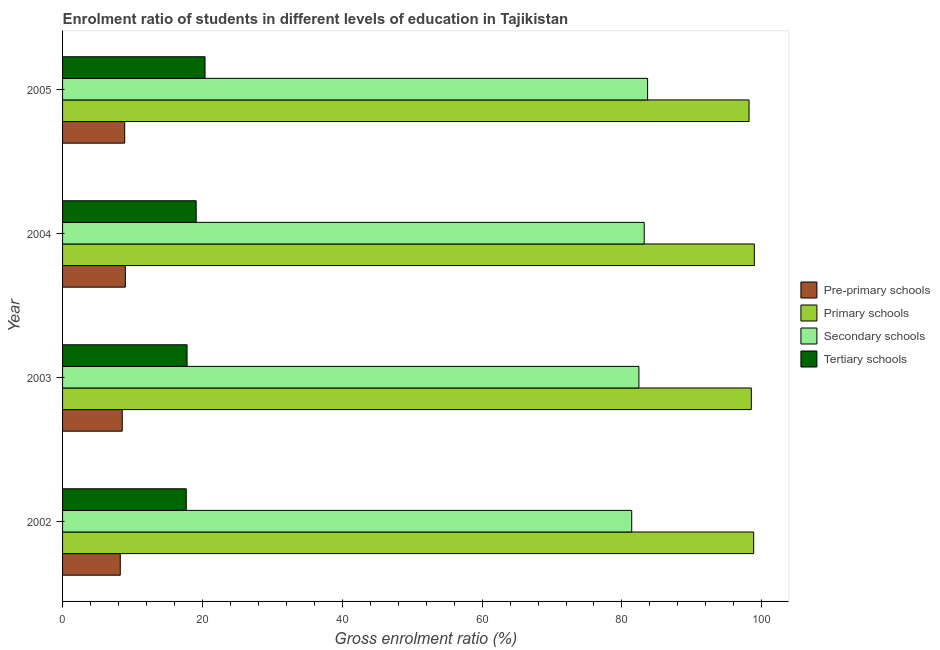How many bars are there on the 2nd tick from the top?
Keep it short and to the point. 4. How many bars are there on the 3rd tick from the bottom?
Keep it short and to the point. 4. What is the label of the 3rd group of bars from the top?
Your answer should be compact. 2003. In how many cases, is the number of bars for a given year not equal to the number of legend labels?
Offer a very short reply. 0. What is the gross enrolment ratio in pre-primary schools in 2005?
Provide a succinct answer. 8.88. Across all years, what is the maximum gross enrolment ratio in tertiary schools?
Your response must be concise. 20.38. Across all years, what is the minimum gross enrolment ratio in tertiary schools?
Provide a short and direct response. 17.69. In which year was the gross enrolment ratio in tertiary schools maximum?
Make the answer very short. 2005. In which year was the gross enrolment ratio in tertiary schools minimum?
Give a very brief answer. 2002. What is the total gross enrolment ratio in tertiary schools in the graph?
Ensure brevity in your answer.  74.98. What is the difference between the gross enrolment ratio in secondary schools in 2003 and that in 2004?
Provide a short and direct response. -0.76. What is the difference between the gross enrolment ratio in primary schools in 2003 and the gross enrolment ratio in tertiary schools in 2002?
Keep it short and to the point. 80.82. What is the average gross enrolment ratio in pre-primary schools per year?
Offer a terse response. 8.66. In the year 2003, what is the difference between the gross enrolment ratio in pre-primary schools and gross enrolment ratio in primary schools?
Keep it short and to the point. -89.97. What is the ratio of the gross enrolment ratio in tertiary schools in 2002 to that in 2003?
Your response must be concise. 0.99. What is the difference between the highest and the second highest gross enrolment ratio in tertiary schools?
Make the answer very short. 1.27. What is the difference between the highest and the lowest gross enrolment ratio in tertiary schools?
Provide a succinct answer. 2.69. In how many years, is the gross enrolment ratio in tertiary schools greater than the average gross enrolment ratio in tertiary schools taken over all years?
Your answer should be very brief. 2. Is the sum of the gross enrolment ratio in secondary schools in 2003 and 2004 greater than the maximum gross enrolment ratio in pre-primary schools across all years?
Keep it short and to the point. Yes. What does the 3rd bar from the top in 2004 represents?
Provide a succinct answer. Primary schools. What does the 4th bar from the bottom in 2005 represents?
Provide a succinct answer. Tertiary schools. Is it the case that in every year, the sum of the gross enrolment ratio in pre-primary schools and gross enrolment ratio in primary schools is greater than the gross enrolment ratio in secondary schools?
Offer a very short reply. Yes. How many bars are there?
Give a very brief answer. 16. What is the difference between two consecutive major ticks on the X-axis?
Make the answer very short. 20. Are the values on the major ticks of X-axis written in scientific E-notation?
Keep it short and to the point. No. Where does the legend appear in the graph?
Provide a short and direct response. Center right. How many legend labels are there?
Offer a very short reply. 4. How are the legend labels stacked?
Keep it short and to the point. Vertical. What is the title of the graph?
Your answer should be very brief. Enrolment ratio of students in different levels of education in Tajikistan. What is the Gross enrolment ratio (%) in Pre-primary schools in 2002?
Keep it short and to the point. 8.25. What is the Gross enrolment ratio (%) in Primary schools in 2002?
Your answer should be compact. 98.84. What is the Gross enrolment ratio (%) of Secondary schools in 2002?
Your answer should be compact. 81.4. What is the Gross enrolment ratio (%) in Tertiary schools in 2002?
Your answer should be very brief. 17.69. What is the Gross enrolment ratio (%) of Pre-primary schools in 2003?
Make the answer very short. 8.54. What is the Gross enrolment ratio (%) of Primary schools in 2003?
Give a very brief answer. 98.51. What is the Gross enrolment ratio (%) in Secondary schools in 2003?
Make the answer very short. 82.43. What is the Gross enrolment ratio (%) of Tertiary schools in 2003?
Give a very brief answer. 17.8. What is the Gross enrolment ratio (%) in Pre-primary schools in 2004?
Your response must be concise. 8.98. What is the Gross enrolment ratio (%) in Primary schools in 2004?
Provide a short and direct response. 98.93. What is the Gross enrolment ratio (%) in Secondary schools in 2004?
Give a very brief answer. 83.19. What is the Gross enrolment ratio (%) in Tertiary schools in 2004?
Ensure brevity in your answer.  19.11. What is the Gross enrolment ratio (%) in Pre-primary schools in 2005?
Offer a terse response. 8.88. What is the Gross enrolment ratio (%) of Primary schools in 2005?
Keep it short and to the point. 98.18. What is the Gross enrolment ratio (%) of Secondary schools in 2005?
Your answer should be compact. 83.67. What is the Gross enrolment ratio (%) of Tertiary schools in 2005?
Offer a very short reply. 20.38. Across all years, what is the maximum Gross enrolment ratio (%) in Pre-primary schools?
Your answer should be compact. 8.98. Across all years, what is the maximum Gross enrolment ratio (%) in Primary schools?
Your answer should be compact. 98.93. Across all years, what is the maximum Gross enrolment ratio (%) of Secondary schools?
Keep it short and to the point. 83.67. Across all years, what is the maximum Gross enrolment ratio (%) in Tertiary schools?
Provide a succinct answer. 20.38. Across all years, what is the minimum Gross enrolment ratio (%) of Pre-primary schools?
Ensure brevity in your answer.  8.25. Across all years, what is the minimum Gross enrolment ratio (%) of Primary schools?
Provide a short and direct response. 98.18. Across all years, what is the minimum Gross enrolment ratio (%) in Secondary schools?
Your response must be concise. 81.4. Across all years, what is the minimum Gross enrolment ratio (%) of Tertiary schools?
Offer a terse response. 17.69. What is the total Gross enrolment ratio (%) in Pre-primary schools in the graph?
Keep it short and to the point. 34.65. What is the total Gross enrolment ratio (%) of Primary schools in the graph?
Provide a short and direct response. 394.47. What is the total Gross enrolment ratio (%) in Secondary schools in the graph?
Ensure brevity in your answer.  330.69. What is the total Gross enrolment ratio (%) of Tertiary schools in the graph?
Ensure brevity in your answer.  74.98. What is the difference between the Gross enrolment ratio (%) in Pre-primary schools in 2002 and that in 2003?
Provide a short and direct response. -0.28. What is the difference between the Gross enrolment ratio (%) of Primary schools in 2002 and that in 2003?
Your answer should be compact. 0.34. What is the difference between the Gross enrolment ratio (%) in Secondary schools in 2002 and that in 2003?
Your answer should be very brief. -1.03. What is the difference between the Gross enrolment ratio (%) of Tertiary schools in 2002 and that in 2003?
Provide a short and direct response. -0.11. What is the difference between the Gross enrolment ratio (%) in Pre-primary schools in 2002 and that in 2004?
Offer a very short reply. -0.72. What is the difference between the Gross enrolment ratio (%) of Primary schools in 2002 and that in 2004?
Offer a terse response. -0.09. What is the difference between the Gross enrolment ratio (%) in Secondary schools in 2002 and that in 2004?
Offer a very short reply. -1.79. What is the difference between the Gross enrolment ratio (%) in Tertiary schools in 2002 and that in 2004?
Your answer should be compact. -1.42. What is the difference between the Gross enrolment ratio (%) of Pre-primary schools in 2002 and that in 2005?
Provide a succinct answer. -0.63. What is the difference between the Gross enrolment ratio (%) in Primary schools in 2002 and that in 2005?
Provide a short and direct response. 0.66. What is the difference between the Gross enrolment ratio (%) of Secondary schools in 2002 and that in 2005?
Give a very brief answer. -2.27. What is the difference between the Gross enrolment ratio (%) of Tertiary schools in 2002 and that in 2005?
Offer a very short reply. -2.69. What is the difference between the Gross enrolment ratio (%) in Pre-primary schools in 2003 and that in 2004?
Your answer should be compact. -0.44. What is the difference between the Gross enrolment ratio (%) of Primary schools in 2003 and that in 2004?
Give a very brief answer. -0.43. What is the difference between the Gross enrolment ratio (%) of Secondary schools in 2003 and that in 2004?
Your answer should be very brief. -0.76. What is the difference between the Gross enrolment ratio (%) of Tertiary schools in 2003 and that in 2004?
Keep it short and to the point. -1.3. What is the difference between the Gross enrolment ratio (%) of Pre-primary schools in 2003 and that in 2005?
Ensure brevity in your answer.  -0.35. What is the difference between the Gross enrolment ratio (%) in Primary schools in 2003 and that in 2005?
Offer a terse response. 0.33. What is the difference between the Gross enrolment ratio (%) in Secondary schools in 2003 and that in 2005?
Provide a short and direct response. -1.24. What is the difference between the Gross enrolment ratio (%) in Tertiary schools in 2003 and that in 2005?
Offer a very short reply. -2.57. What is the difference between the Gross enrolment ratio (%) of Pre-primary schools in 2004 and that in 2005?
Offer a terse response. 0.09. What is the difference between the Gross enrolment ratio (%) in Primary schools in 2004 and that in 2005?
Your answer should be very brief. 0.75. What is the difference between the Gross enrolment ratio (%) of Secondary schools in 2004 and that in 2005?
Your response must be concise. -0.49. What is the difference between the Gross enrolment ratio (%) of Tertiary schools in 2004 and that in 2005?
Your answer should be compact. -1.27. What is the difference between the Gross enrolment ratio (%) in Pre-primary schools in 2002 and the Gross enrolment ratio (%) in Primary schools in 2003?
Your answer should be very brief. -90.26. What is the difference between the Gross enrolment ratio (%) in Pre-primary schools in 2002 and the Gross enrolment ratio (%) in Secondary schools in 2003?
Your answer should be very brief. -74.18. What is the difference between the Gross enrolment ratio (%) of Pre-primary schools in 2002 and the Gross enrolment ratio (%) of Tertiary schools in 2003?
Give a very brief answer. -9.55. What is the difference between the Gross enrolment ratio (%) of Primary schools in 2002 and the Gross enrolment ratio (%) of Secondary schools in 2003?
Give a very brief answer. 16.41. What is the difference between the Gross enrolment ratio (%) in Primary schools in 2002 and the Gross enrolment ratio (%) in Tertiary schools in 2003?
Provide a short and direct response. 81.04. What is the difference between the Gross enrolment ratio (%) of Secondary schools in 2002 and the Gross enrolment ratio (%) of Tertiary schools in 2003?
Your answer should be very brief. 63.6. What is the difference between the Gross enrolment ratio (%) of Pre-primary schools in 2002 and the Gross enrolment ratio (%) of Primary schools in 2004?
Your answer should be very brief. -90.68. What is the difference between the Gross enrolment ratio (%) in Pre-primary schools in 2002 and the Gross enrolment ratio (%) in Secondary schools in 2004?
Your answer should be very brief. -74.93. What is the difference between the Gross enrolment ratio (%) of Pre-primary schools in 2002 and the Gross enrolment ratio (%) of Tertiary schools in 2004?
Your response must be concise. -10.86. What is the difference between the Gross enrolment ratio (%) in Primary schools in 2002 and the Gross enrolment ratio (%) in Secondary schools in 2004?
Provide a succinct answer. 15.66. What is the difference between the Gross enrolment ratio (%) of Primary schools in 2002 and the Gross enrolment ratio (%) of Tertiary schools in 2004?
Give a very brief answer. 79.73. What is the difference between the Gross enrolment ratio (%) of Secondary schools in 2002 and the Gross enrolment ratio (%) of Tertiary schools in 2004?
Offer a terse response. 62.29. What is the difference between the Gross enrolment ratio (%) of Pre-primary schools in 2002 and the Gross enrolment ratio (%) of Primary schools in 2005?
Keep it short and to the point. -89.93. What is the difference between the Gross enrolment ratio (%) in Pre-primary schools in 2002 and the Gross enrolment ratio (%) in Secondary schools in 2005?
Offer a terse response. -75.42. What is the difference between the Gross enrolment ratio (%) of Pre-primary schools in 2002 and the Gross enrolment ratio (%) of Tertiary schools in 2005?
Give a very brief answer. -12.12. What is the difference between the Gross enrolment ratio (%) of Primary schools in 2002 and the Gross enrolment ratio (%) of Secondary schools in 2005?
Offer a terse response. 15.17. What is the difference between the Gross enrolment ratio (%) in Primary schools in 2002 and the Gross enrolment ratio (%) in Tertiary schools in 2005?
Give a very brief answer. 78.47. What is the difference between the Gross enrolment ratio (%) in Secondary schools in 2002 and the Gross enrolment ratio (%) in Tertiary schools in 2005?
Your answer should be very brief. 61.03. What is the difference between the Gross enrolment ratio (%) of Pre-primary schools in 2003 and the Gross enrolment ratio (%) of Primary schools in 2004?
Keep it short and to the point. -90.4. What is the difference between the Gross enrolment ratio (%) of Pre-primary schools in 2003 and the Gross enrolment ratio (%) of Secondary schools in 2004?
Your response must be concise. -74.65. What is the difference between the Gross enrolment ratio (%) of Pre-primary schools in 2003 and the Gross enrolment ratio (%) of Tertiary schools in 2004?
Give a very brief answer. -10.57. What is the difference between the Gross enrolment ratio (%) in Primary schools in 2003 and the Gross enrolment ratio (%) in Secondary schools in 2004?
Offer a terse response. 15.32. What is the difference between the Gross enrolment ratio (%) in Primary schools in 2003 and the Gross enrolment ratio (%) in Tertiary schools in 2004?
Your answer should be compact. 79.4. What is the difference between the Gross enrolment ratio (%) of Secondary schools in 2003 and the Gross enrolment ratio (%) of Tertiary schools in 2004?
Your answer should be very brief. 63.32. What is the difference between the Gross enrolment ratio (%) of Pre-primary schools in 2003 and the Gross enrolment ratio (%) of Primary schools in 2005?
Make the answer very short. -89.65. What is the difference between the Gross enrolment ratio (%) in Pre-primary schools in 2003 and the Gross enrolment ratio (%) in Secondary schools in 2005?
Give a very brief answer. -75.14. What is the difference between the Gross enrolment ratio (%) in Pre-primary schools in 2003 and the Gross enrolment ratio (%) in Tertiary schools in 2005?
Provide a short and direct response. -11.84. What is the difference between the Gross enrolment ratio (%) in Primary schools in 2003 and the Gross enrolment ratio (%) in Secondary schools in 2005?
Your answer should be compact. 14.83. What is the difference between the Gross enrolment ratio (%) in Primary schools in 2003 and the Gross enrolment ratio (%) in Tertiary schools in 2005?
Give a very brief answer. 78.13. What is the difference between the Gross enrolment ratio (%) in Secondary schools in 2003 and the Gross enrolment ratio (%) in Tertiary schools in 2005?
Your answer should be very brief. 62.05. What is the difference between the Gross enrolment ratio (%) of Pre-primary schools in 2004 and the Gross enrolment ratio (%) of Primary schools in 2005?
Offer a very short reply. -89.21. What is the difference between the Gross enrolment ratio (%) of Pre-primary schools in 2004 and the Gross enrolment ratio (%) of Secondary schools in 2005?
Ensure brevity in your answer.  -74.7. What is the difference between the Gross enrolment ratio (%) in Pre-primary schools in 2004 and the Gross enrolment ratio (%) in Tertiary schools in 2005?
Provide a succinct answer. -11.4. What is the difference between the Gross enrolment ratio (%) in Primary schools in 2004 and the Gross enrolment ratio (%) in Secondary schools in 2005?
Provide a short and direct response. 15.26. What is the difference between the Gross enrolment ratio (%) in Primary schools in 2004 and the Gross enrolment ratio (%) in Tertiary schools in 2005?
Provide a succinct answer. 78.56. What is the difference between the Gross enrolment ratio (%) in Secondary schools in 2004 and the Gross enrolment ratio (%) in Tertiary schools in 2005?
Keep it short and to the point. 62.81. What is the average Gross enrolment ratio (%) of Pre-primary schools per year?
Provide a succinct answer. 8.66. What is the average Gross enrolment ratio (%) of Primary schools per year?
Give a very brief answer. 98.62. What is the average Gross enrolment ratio (%) of Secondary schools per year?
Provide a succinct answer. 82.67. What is the average Gross enrolment ratio (%) in Tertiary schools per year?
Offer a terse response. 18.74. In the year 2002, what is the difference between the Gross enrolment ratio (%) of Pre-primary schools and Gross enrolment ratio (%) of Primary schools?
Provide a short and direct response. -90.59. In the year 2002, what is the difference between the Gross enrolment ratio (%) of Pre-primary schools and Gross enrolment ratio (%) of Secondary schools?
Your answer should be very brief. -73.15. In the year 2002, what is the difference between the Gross enrolment ratio (%) in Pre-primary schools and Gross enrolment ratio (%) in Tertiary schools?
Ensure brevity in your answer.  -9.44. In the year 2002, what is the difference between the Gross enrolment ratio (%) in Primary schools and Gross enrolment ratio (%) in Secondary schools?
Offer a terse response. 17.44. In the year 2002, what is the difference between the Gross enrolment ratio (%) of Primary schools and Gross enrolment ratio (%) of Tertiary schools?
Keep it short and to the point. 81.15. In the year 2002, what is the difference between the Gross enrolment ratio (%) in Secondary schools and Gross enrolment ratio (%) in Tertiary schools?
Offer a very short reply. 63.71. In the year 2003, what is the difference between the Gross enrolment ratio (%) in Pre-primary schools and Gross enrolment ratio (%) in Primary schools?
Offer a very short reply. -89.97. In the year 2003, what is the difference between the Gross enrolment ratio (%) of Pre-primary schools and Gross enrolment ratio (%) of Secondary schools?
Make the answer very short. -73.89. In the year 2003, what is the difference between the Gross enrolment ratio (%) of Pre-primary schools and Gross enrolment ratio (%) of Tertiary schools?
Ensure brevity in your answer.  -9.27. In the year 2003, what is the difference between the Gross enrolment ratio (%) in Primary schools and Gross enrolment ratio (%) in Secondary schools?
Ensure brevity in your answer.  16.08. In the year 2003, what is the difference between the Gross enrolment ratio (%) of Primary schools and Gross enrolment ratio (%) of Tertiary schools?
Provide a short and direct response. 80.7. In the year 2003, what is the difference between the Gross enrolment ratio (%) in Secondary schools and Gross enrolment ratio (%) in Tertiary schools?
Make the answer very short. 64.62. In the year 2004, what is the difference between the Gross enrolment ratio (%) in Pre-primary schools and Gross enrolment ratio (%) in Primary schools?
Provide a short and direct response. -89.96. In the year 2004, what is the difference between the Gross enrolment ratio (%) in Pre-primary schools and Gross enrolment ratio (%) in Secondary schools?
Offer a very short reply. -74.21. In the year 2004, what is the difference between the Gross enrolment ratio (%) in Pre-primary schools and Gross enrolment ratio (%) in Tertiary schools?
Give a very brief answer. -10.13. In the year 2004, what is the difference between the Gross enrolment ratio (%) of Primary schools and Gross enrolment ratio (%) of Secondary schools?
Your answer should be compact. 15.75. In the year 2004, what is the difference between the Gross enrolment ratio (%) of Primary schools and Gross enrolment ratio (%) of Tertiary schools?
Provide a succinct answer. 79.82. In the year 2004, what is the difference between the Gross enrolment ratio (%) of Secondary schools and Gross enrolment ratio (%) of Tertiary schools?
Keep it short and to the point. 64.08. In the year 2005, what is the difference between the Gross enrolment ratio (%) in Pre-primary schools and Gross enrolment ratio (%) in Primary schools?
Your answer should be very brief. -89.3. In the year 2005, what is the difference between the Gross enrolment ratio (%) of Pre-primary schools and Gross enrolment ratio (%) of Secondary schools?
Keep it short and to the point. -74.79. In the year 2005, what is the difference between the Gross enrolment ratio (%) of Pre-primary schools and Gross enrolment ratio (%) of Tertiary schools?
Your answer should be very brief. -11.49. In the year 2005, what is the difference between the Gross enrolment ratio (%) in Primary schools and Gross enrolment ratio (%) in Secondary schools?
Provide a succinct answer. 14.51. In the year 2005, what is the difference between the Gross enrolment ratio (%) of Primary schools and Gross enrolment ratio (%) of Tertiary schools?
Offer a very short reply. 77.81. In the year 2005, what is the difference between the Gross enrolment ratio (%) of Secondary schools and Gross enrolment ratio (%) of Tertiary schools?
Offer a terse response. 63.3. What is the ratio of the Gross enrolment ratio (%) of Pre-primary schools in 2002 to that in 2003?
Keep it short and to the point. 0.97. What is the ratio of the Gross enrolment ratio (%) in Primary schools in 2002 to that in 2003?
Provide a short and direct response. 1. What is the ratio of the Gross enrolment ratio (%) of Secondary schools in 2002 to that in 2003?
Offer a very short reply. 0.99. What is the ratio of the Gross enrolment ratio (%) of Tertiary schools in 2002 to that in 2003?
Your answer should be very brief. 0.99. What is the ratio of the Gross enrolment ratio (%) of Pre-primary schools in 2002 to that in 2004?
Give a very brief answer. 0.92. What is the ratio of the Gross enrolment ratio (%) in Secondary schools in 2002 to that in 2004?
Provide a succinct answer. 0.98. What is the ratio of the Gross enrolment ratio (%) in Tertiary schools in 2002 to that in 2004?
Provide a short and direct response. 0.93. What is the ratio of the Gross enrolment ratio (%) in Pre-primary schools in 2002 to that in 2005?
Provide a succinct answer. 0.93. What is the ratio of the Gross enrolment ratio (%) of Secondary schools in 2002 to that in 2005?
Your response must be concise. 0.97. What is the ratio of the Gross enrolment ratio (%) of Tertiary schools in 2002 to that in 2005?
Your answer should be compact. 0.87. What is the ratio of the Gross enrolment ratio (%) in Pre-primary schools in 2003 to that in 2004?
Offer a terse response. 0.95. What is the ratio of the Gross enrolment ratio (%) in Primary schools in 2003 to that in 2004?
Keep it short and to the point. 1. What is the ratio of the Gross enrolment ratio (%) in Secondary schools in 2003 to that in 2004?
Your answer should be very brief. 0.99. What is the ratio of the Gross enrolment ratio (%) in Tertiary schools in 2003 to that in 2004?
Give a very brief answer. 0.93. What is the ratio of the Gross enrolment ratio (%) of Pre-primary schools in 2003 to that in 2005?
Your answer should be very brief. 0.96. What is the ratio of the Gross enrolment ratio (%) of Secondary schools in 2003 to that in 2005?
Offer a terse response. 0.99. What is the ratio of the Gross enrolment ratio (%) in Tertiary schools in 2003 to that in 2005?
Keep it short and to the point. 0.87. What is the ratio of the Gross enrolment ratio (%) in Pre-primary schools in 2004 to that in 2005?
Your response must be concise. 1.01. What is the ratio of the Gross enrolment ratio (%) of Primary schools in 2004 to that in 2005?
Offer a very short reply. 1.01. What is the ratio of the Gross enrolment ratio (%) of Secondary schools in 2004 to that in 2005?
Make the answer very short. 0.99. What is the ratio of the Gross enrolment ratio (%) of Tertiary schools in 2004 to that in 2005?
Provide a short and direct response. 0.94. What is the difference between the highest and the second highest Gross enrolment ratio (%) in Pre-primary schools?
Keep it short and to the point. 0.09. What is the difference between the highest and the second highest Gross enrolment ratio (%) of Primary schools?
Your answer should be compact. 0.09. What is the difference between the highest and the second highest Gross enrolment ratio (%) in Secondary schools?
Your answer should be very brief. 0.49. What is the difference between the highest and the second highest Gross enrolment ratio (%) of Tertiary schools?
Keep it short and to the point. 1.27. What is the difference between the highest and the lowest Gross enrolment ratio (%) in Pre-primary schools?
Your response must be concise. 0.72. What is the difference between the highest and the lowest Gross enrolment ratio (%) of Primary schools?
Offer a terse response. 0.75. What is the difference between the highest and the lowest Gross enrolment ratio (%) of Secondary schools?
Offer a very short reply. 2.27. What is the difference between the highest and the lowest Gross enrolment ratio (%) in Tertiary schools?
Give a very brief answer. 2.69. 